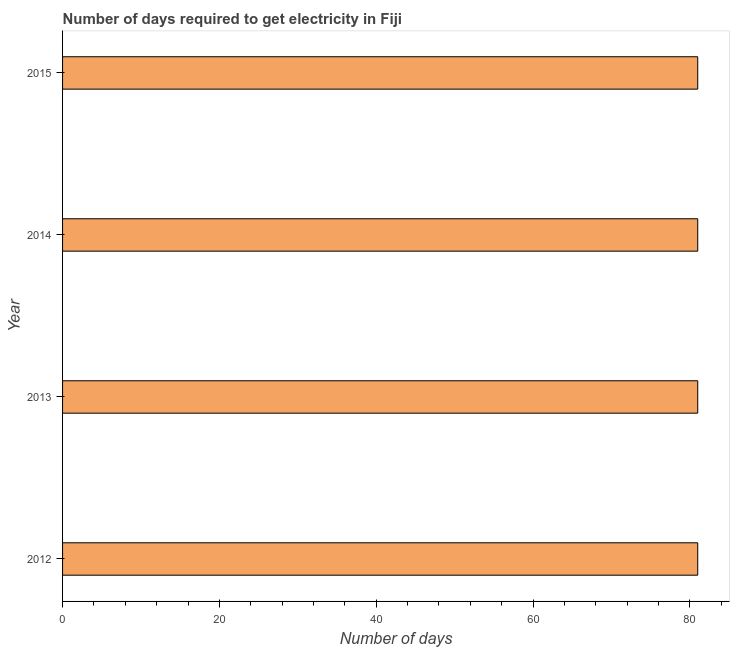What is the title of the graph?
Your response must be concise. Number of days required to get electricity in Fiji. What is the label or title of the X-axis?
Offer a terse response. Number of days. What is the time to get electricity in 2015?
Provide a short and direct response. 81. In which year was the time to get electricity minimum?
Provide a short and direct response. 2012. What is the sum of the time to get electricity?
Provide a short and direct response. 324. What is the difference between the time to get electricity in 2014 and 2015?
Your answer should be compact. 0. What is the median time to get electricity?
Offer a terse response. 81. What is the ratio of the time to get electricity in 2014 to that in 2015?
Your answer should be very brief. 1. Is the time to get electricity in 2012 less than that in 2015?
Provide a short and direct response. No. Is the sum of the time to get electricity in 2014 and 2015 greater than the maximum time to get electricity across all years?
Your answer should be compact. Yes. In how many years, is the time to get electricity greater than the average time to get electricity taken over all years?
Give a very brief answer. 0. How many years are there in the graph?
Make the answer very short. 4. Are the values on the major ticks of X-axis written in scientific E-notation?
Provide a short and direct response. No. What is the Number of days in 2014?
Your answer should be compact. 81. What is the difference between the Number of days in 2012 and 2014?
Make the answer very short. 0. What is the difference between the Number of days in 2013 and 2014?
Make the answer very short. 0. What is the difference between the Number of days in 2014 and 2015?
Ensure brevity in your answer.  0. What is the ratio of the Number of days in 2012 to that in 2014?
Keep it short and to the point. 1. What is the ratio of the Number of days in 2012 to that in 2015?
Provide a succinct answer. 1. 